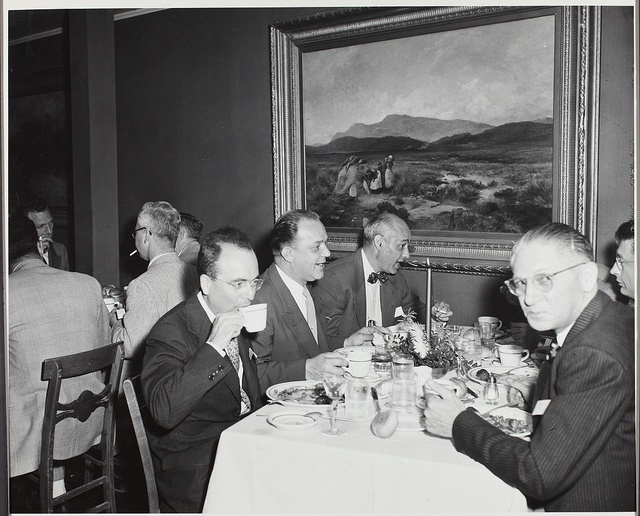Describe the objects in this image and their specific colors. I can see dining table in gray, lightgray, darkgray, and black tones, people in gray, black, lightgray, and darkgray tones, people in gray, black, lightgray, and darkgray tones, people in gray, darkgray, black, and lightgray tones, and people in gray, lightgray, darkgray, and black tones in this image. 